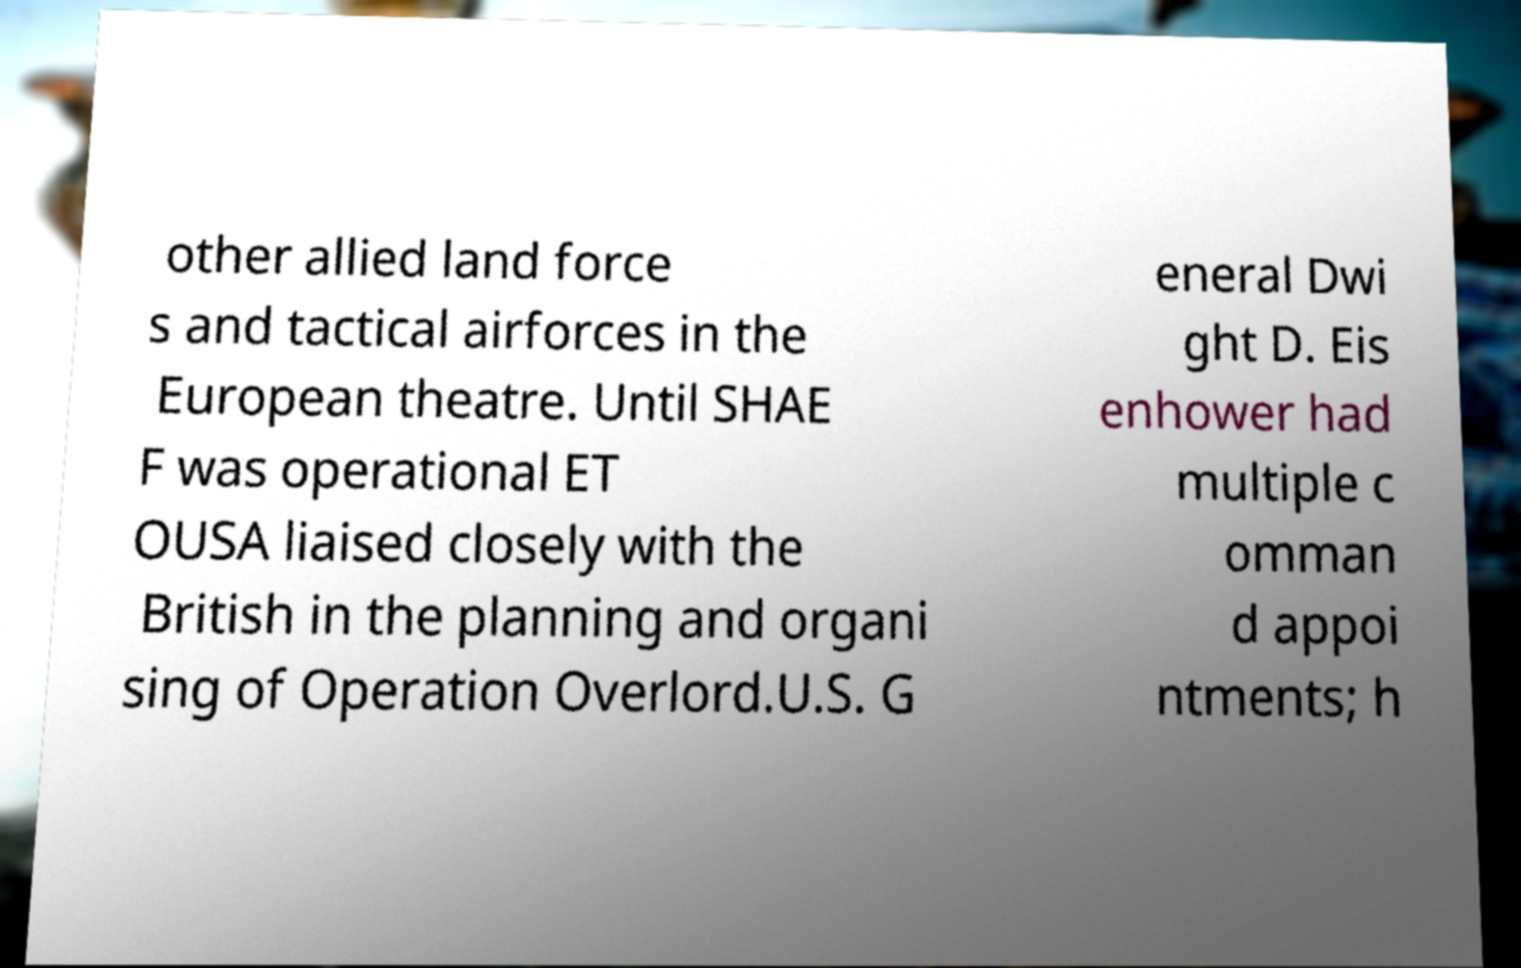Could you extract and type out the text from this image? other allied land force s and tactical airforces in the European theatre. Until SHAE F was operational ET OUSA liaised closely with the British in the planning and organi sing of Operation Overlord.U.S. G eneral Dwi ght D. Eis enhower had multiple c omman d appoi ntments; h 